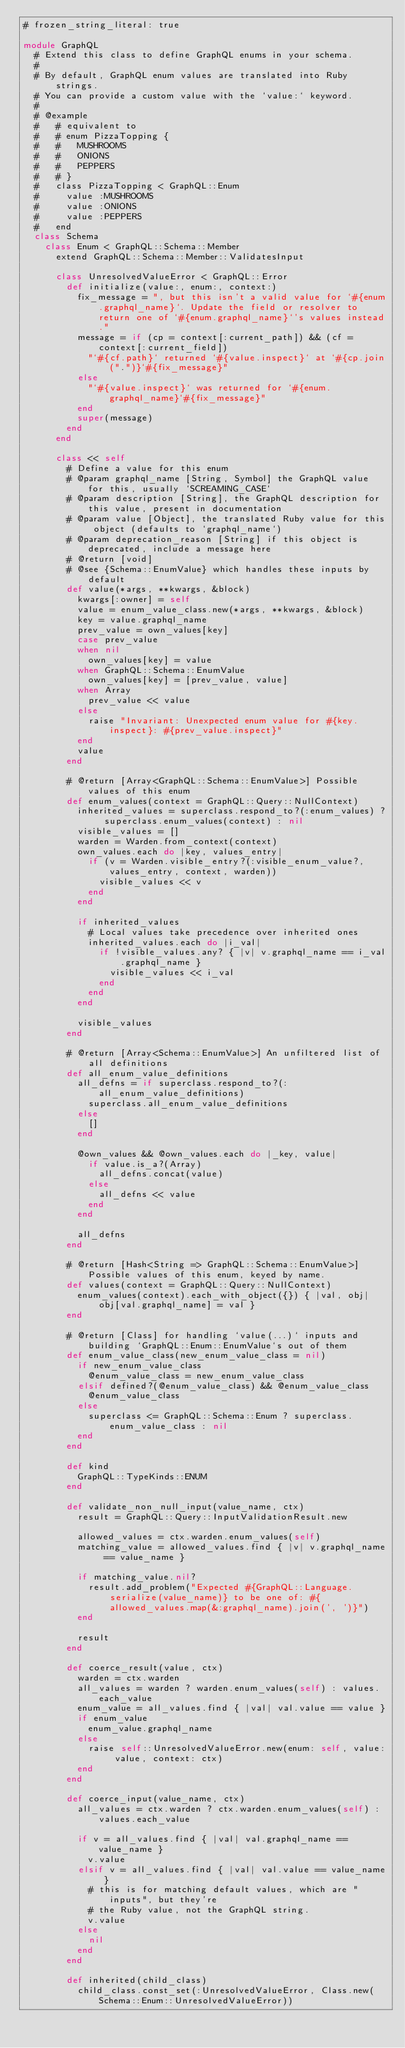Convert code to text. <code><loc_0><loc_0><loc_500><loc_500><_Ruby_># frozen_string_literal: true

module GraphQL
  # Extend this class to define GraphQL enums in your schema.
  #
  # By default, GraphQL enum values are translated into Ruby strings.
  # You can provide a custom value with the `value:` keyword.
  #
  # @example
  #   # equivalent to
  #   # enum PizzaTopping {
  #   #   MUSHROOMS
  #   #   ONIONS
  #   #   PEPPERS
  #   # }
  #   class PizzaTopping < GraphQL::Enum
  #     value :MUSHROOMS
  #     value :ONIONS
  #     value :PEPPERS
  #   end
  class Schema
    class Enum < GraphQL::Schema::Member
      extend GraphQL::Schema::Member::ValidatesInput

      class UnresolvedValueError < GraphQL::Error
        def initialize(value:, enum:, context:)
          fix_message = ", but this isn't a valid value for `#{enum.graphql_name}`. Update the field or resolver to return one of `#{enum.graphql_name}`'s values instead."
          message = if (cp = context[:current_path]) && (cf = context[:current_field])
            "`#{cf.path}` returned `#{value.inspect}` at `#{cp.join(".")}`#{fix_message}"
          else
            "`#{value.inspect}` was returned for `#{enum.graphql_name}`#{fix_message}"
          end
          super(message)
        end
      end

      class << self
        # Define a value for this enum
        # @param graphql_name [String, Symbol] the GraphQL value for this, usually `SCREAMING_CASE`
        # @param description [String], the GraphQL description for this value, present in documentation
        # @param value [Object], the translated Ruby value for this object (defaults to `graphql_name`)
        # @param deprecation_reason [String] if this object is deprecated, include a message here
        # @return [void]
        # @see {Schema::EnumValue} which handles these inputs by default
        def value(*args, **kwargs, &block)
          kwargs[:owner] = self
          value = enum_value_class.new(*args, **kwargs, &block)
          key = value.graphql_name
          prev_value = own_values[key]
          case prev_value
          when nil
            own_values[key] = value
          when GraphQL::Schema::EnumValue
            own_values[key] = [prev_value, value]
          when Array
            prev_value << value
          else
            raise "Invariant: Unexpected enum value for #{key.inspect}: #{prev_value.inspect}"
          end
          value
        end

        # @return [Array<GraphQL::Schema::EnumValue>] Possible values of this enum
        def enum_values(context = GraphQL::Query::NullContext)
          inherited_values = superclass.respond_to?(:enum_values) ? superclass.enum_values(context) : nil
          visible_values = []
          warden = Warden.from_context(context)
          own_values.each do |key, values_entry|
            if (v = Warden.visible_entry?(:visible_enum_value?, values_entry, context, warden))
              visible_values << v
            end
          end

          if inherited_values
            # Local values take precedence over inherited ones
            inherited_values.each do |i_val|
              if !visible_values.any? { |v| v.graphql_name == i_val.graphql_name }
                visible_values << i_val
              end
            end
          end

          visible_values
        end

        # @return [Array<Schema::EnumValue>] An unfiltered list of all definitions
        def all_enum_value_definitions
          all_defns = if superclass.respond_to?(:all_enum_value_definitions)
            superclass.all_enum_value_definitions
          else
            []
          end

          @own_values && @own_values.each do |_key, value|
            if value.is_a?(Array)
              all_defns.concat(value)
            else
              all_defns << value
            end
          end

          all_defns
        end

        # @return [Hash<String => GraphQL::Schema::EnumValue>] Possible values of this enum, keyed by name.
        def values(context = GraphQL::Query::NullContext)
          enum_values(context).each_with_object({}) { |val, obj| obj[val.graphql_name] = val }
        end

        # @return [Class] for handling `value(...)` inputs and building `GraphQL::Enum::EnumValue`s out of them
        def enum_value_class(new_enum_value_class = nil)
          if new_enum_value_class
            @enum_value_class = new_enum_value_class
          elsif defined?(@enum_value_class) && @enum_value_class
            @enum_value_class
          else
            superclass <= GraphQL::Schema::Enum ? superclass.enum_value_class : nil
          end
        end

        def kind
          GraphQL::TypeKinds::ENUM
        end

        def validate_non_null_input(value_name, ctx)
          result = GraphQL::Query::InputValidationResult.new

          allowed_values = ctx.warden.enum_values(self)
          matching_value = allowed_values.find { |v| v.graphql_name == value_name }

          if matching_value.nil?
            result.add_problem("Expected #{GraphQL::Language.serialize(value_name)} to be one of: #{allowed_values.map(&:graphql_name).join(', ')}")
          end

          result
        end

        def coerce_result(value, ctx)
          warden = ctx.warden
          all_values = warden ? warden.enum_values(self) : values.each_value
          enum_value = all_values.find { |val| val.value == value }
          if enum_value
            enum_value.graphql_name
          else
            raise self::UnresolvedValueError.new(enum: self, value: value, context: ctx)
          end
        end

        def coerce_input(value_name, ctx)
          all_values = ctx.warden ? ctx.warden.enum_values(self) : values.each_value

          if v = all_values.find { |val| val.graphql_name == value_name }
            v.value
          elsif v = all_values.find { |val| val.value == value_name }
            # this is for matching default values, which are "inputs", but they're
            # the Ruby value, not the GraphQL string.
            v.value
          else
            nil
          end
        end

        def inherited(child_class)
          child_class.const_set(:UnresolvedValueError, Class.new(Schema::Enum::UnresolvedValueError))</code> 